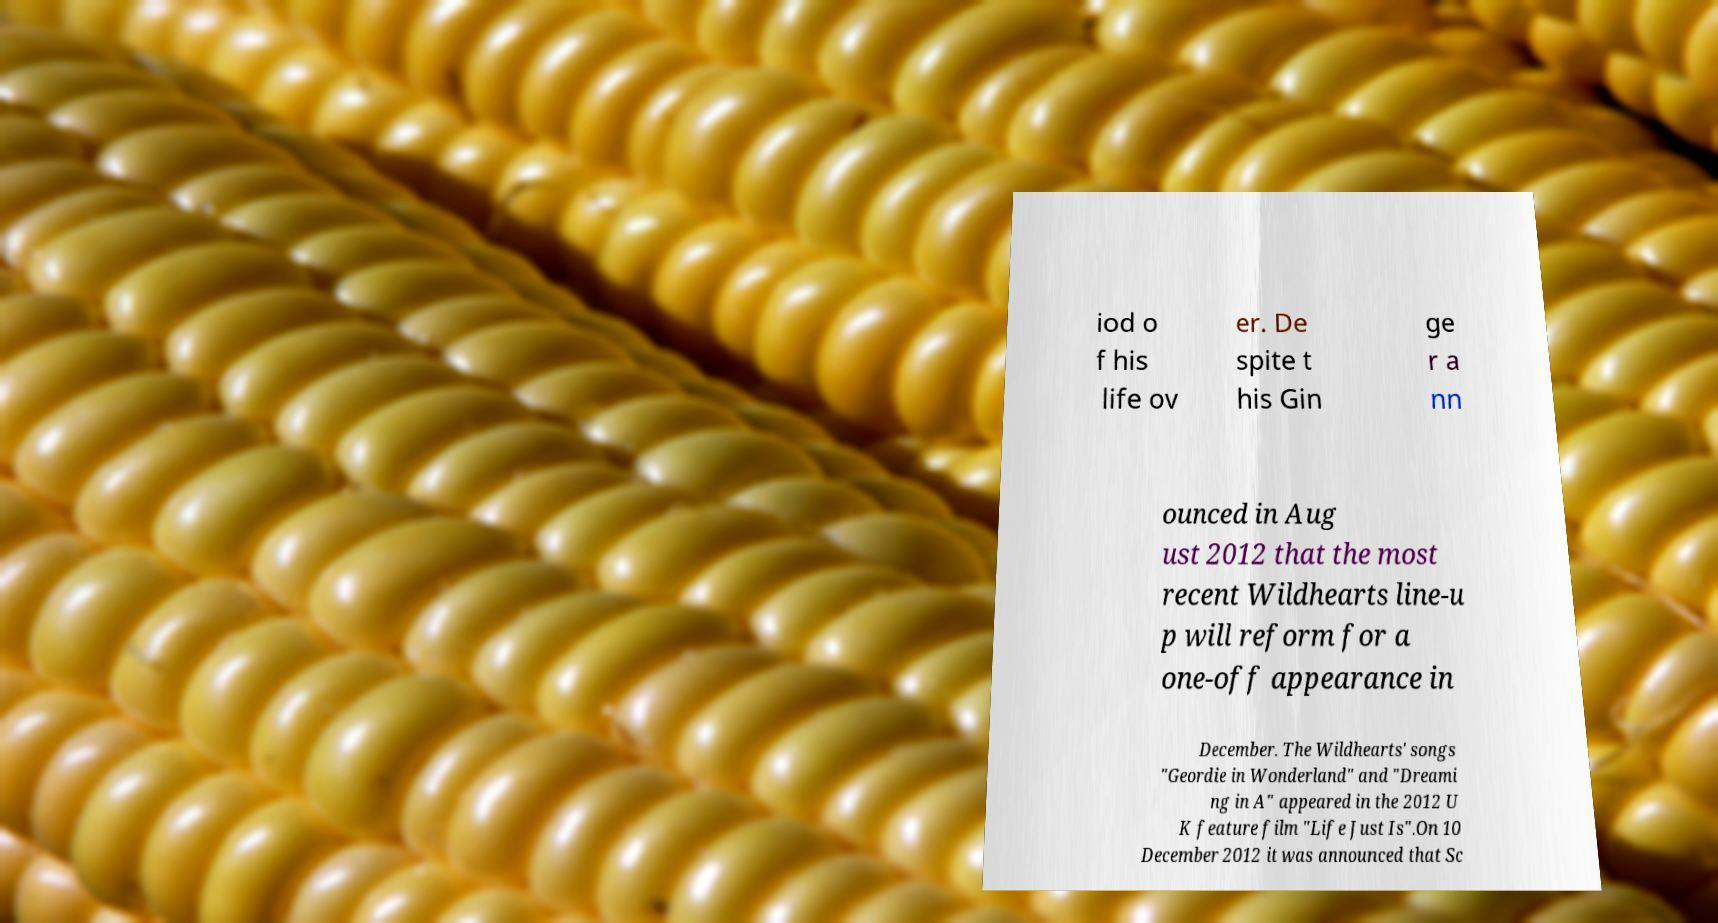Can you read and provide the text displayed in the image?This photo seems to have some interesting text. Can you extract and type it out for me? iod o f his life ov er. De spite t his Gin ge r a nn ounced in Aug ust 2012 that the most recent Wildhearts line-u p will reform for a one-off appearance in December. The Wildhearts' songs "Geordie in Wonderland" and "Dreami ng in A" appeared in the 2012 U K feature film "Life Just Is".On 10 December 2012 it was announced that Sc 